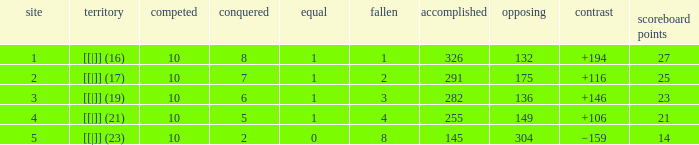 How many table points are listed for the deficit is +194?  1.0. 